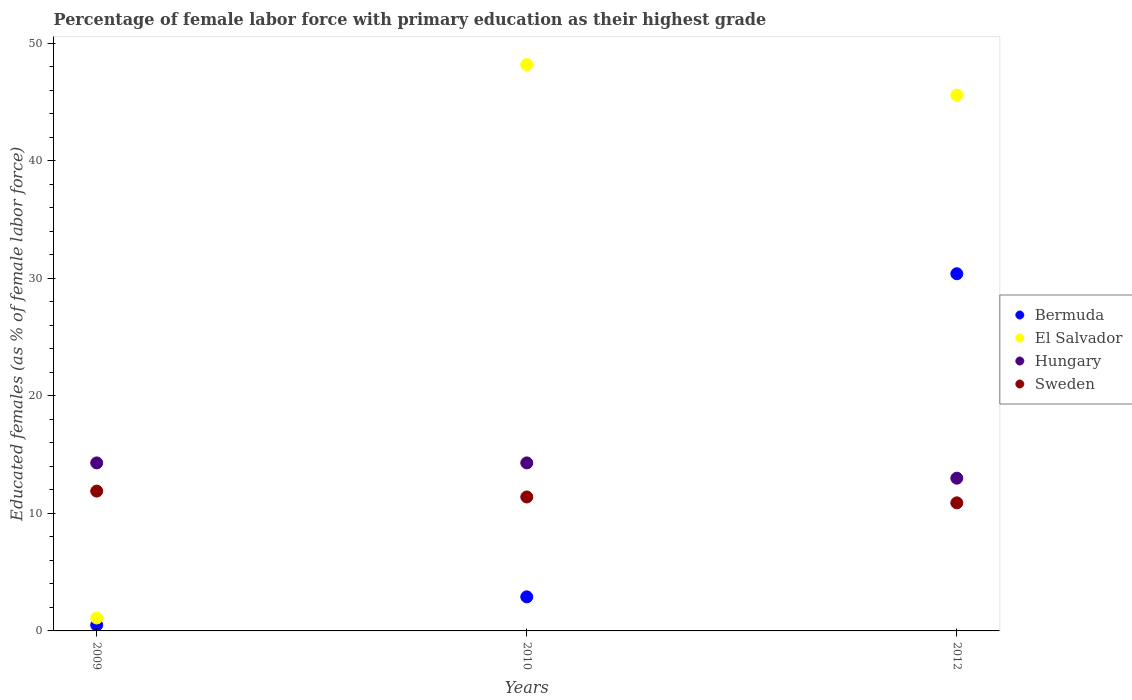What is the percentage of female labor force with primary education in Hungary in 2012?
Keep it short and to the point. 13. Across all years, what is the maximum percentage of female labor force with primary education in El Salvador?
Keep it short and to the point. 48.2. Across all years, what is the minimum percentage of female labor force with primary education in El Salvador?
Your answer should be very brief. 1.1. What is the total percentage of female labor force with primary education in El Salvador in the graph?
Give a very brief answer. 94.9. What is the difference between the percentage of female labor force with primary education in El Salvador in 2010 and that in 2012?
Your answer should be compact. 2.6. What is the difference between the percentage of female labor force with primary education in Sweden in 2009 and the percentage of female labor force with primary education in Bermuda in 2012?
Your response must be concise. -18.5. What is the average percentage of female labor force with primary education in Sweden per year?
Your answer should be very brief. 11.4. In the year 2009, what is the difference between the percentage of female labor force with primary education in Sweden and percentage of female labor force with primary education in Hungary?
Provide a succinct answer. -2.4. In how many years, is the percentage of female labor force with primary education in El Salvador greater than 34 %?
Provide a succinct answer. 2. What is the ratio of the percentage of female labor force with primary education in El Salvador in 2009 to that in 2010?
Offer a very short reply. 0.02. What is the difference between the highest and the lowest percentage of female labor force with primary education in Bermuda?
Make the answer very short. 29.9. In how many years, is the percentage of female labor force with primary education in Bermuda greater than the average percentage of female labor force with primary education in Bermuda taken over all years?
Make the answer very short. 1. Is the sum of the percentage of female labor force with primary education in Bermuda in 2009 and 2012 greater than the maximum percentage of female labor force with primary education in El Salvador across all years?
Offer a terse response. No. Does the percentage of female labor force with primary education in Hungary monotonically increase over the years?
Your answer should be compact. No. Is the percentage of female labor force with primary education in Bermuda strictly less than the percentage of female labor force with primary education in Hungary over the years?
Your answer should be compact. No. How many dotlines are there?
Your answer should be very brief. 4. What is the difference between two consecutive major ticks on the Y-axis?
Keep it short and to the point. 10. Are the values on the major ticks of Y-axis written in scientific E-notation?
Offer a terse response. No. Where does the legend appear in the graph?
Keep it short and to the point. Center right. How many legend labels are there?
Provide a short and direct response. 4. How are the legend labels stacked?
Make the answer very short. Vertical. What is the title of the graph?
Offer a very short reply. Percentage of female labor force with primary education as their highest grade. What is the label or title of the Y-axis?
Provide a short and direct response. Educated females (as % of female labor force). What is the Educated females (as % of female labor force) in Bermuda in 2009?
Provide a short and direct response. 0.5. What is the Educated females (as % of female labor force) in El Salvador in 2009?
Your answer should be very brief. 1.1. What is the Educated females (as % of female labor force) of Hungary in 2009?
Provide a succinct answer. 14.3. What is the Educated females (as % of female labor force) in Sweden in 2009?
Offer a terse response. 11.9. What is the Educated females (as % of female labor force) in Bermuda in 2010?
Provide a short and direct response. 2.9. What is the Educated females (as % of female labor force) in El Salvador in 2010?
Your response must be concise. 48.2. What is the Educated females (as % of female labor force) in Hungary in 2010?
Your answer should be compact. 14.3. What is the Educated females (as % of female labor force) in Sweden in 2010?
Offer a terse response. 11.4. What is the Educated females (as % of female labor force) in Bermuda in 2012?
Ensure brevity in your answer.  30.4. What is the Educated females (as % of female labor force) of El Salvador in 2012?
Offer a terse response. 45.6. What is the Educated females (as % of female labor force) of Hungary in 2012?
Make the answer very short. 13. What is the Educated females (as % of female labor force) in Sweden in 2012?
Keep it short and to the point. 10.9. Across all years, what is the maximum Educated females (as % of female labor force) in Bermuda?
Provide a succinct answer. 30.4. Across all years, what is the maximum Educated females (as % of female labor force) in El Salvador?
Give a very brief answer. 48.2. Across all years, what is the maximum Educated females (as % of female labor force) of Hungary?
Offer a terse response. 14.3. Across all years, what is the maximum Educated females (as % of female labor force) in Sweden?
Offer a terse response. 11.9. Across all years, what is the minimum Educated females (as % of female labor force) of Bermuda?
Your answer should be compact. 0.5. Across all years, what is the minimum Educated females (as % of female labor force) in El Salvador?
Give a very brief answer. 1.1. Across all years, what is the minimum Educated females (as % of female labor force) in Sweden?
Your answer should be compact. 10.9. What is the total Educated females (as % of female labor force) of Bermuda in the graph?
Provide a succinct answer. 33.8. What is the total Educated females (as % of female labor force) of El Salvador in the graph?
Your answer should be very brief. 94.9. What is the total Educated females (as % of female labor force) of Hungary in the graph?
Provide a short and direct response. 41.6. What is the total Educated females (as % of female labor force) in Sweden in the graph?
Provide a succinct answer. 34.2. What is the difference between the Educated females (as % of female labor force) in Bermuda in 2009 and that in 2010?
Your answer should be very brief. -2.4. What is the difference between the Educated females (as % of female labor force) in El Salvador in 2009 and that in 2010?
Ensure brevity in your answer.  -47.1. What is the difference between the Educated females (as % of female labor force) in Sweden in 2009 and that in 2010?
Offer a very short reply. 0.5. What is the difference between the Educated females (as % of female labor force) in Bermuda in 2009 and that in 2012?
Your response must be concise. -29.9. What is the difference between the Educated females (as % of female labor force) in El Salvador in 2009 and that in 2012?
Give a very brief answer. -44.5. What is the difference between the Educated females (as % of female labor force) of Bermuda in 2010 and that in 2012?
Give a very brief answer. -27.5. What is the difference between the Educated females (as % of female labor force) in El Salvador in 2010 and that in 2012?
Your response must be concise. 2.6. What is the difference between the Educated females (as % of female labor force) of Sweden in 2010 and that in 2012?
Your response must be concise. 0.5. What is the difference between the Educated females (as % of female labor force) of Bermuda in 2009 and the Educated females (as % of female labor force) of El Salvador in 2010?
Offer a very short reply. -47.7. What is the difference between the Educated females (as % of female labor force) of Bermuda in 2009 and the Educated females (as % of female labor force) of Hungary in 2010?
Keep it short and to the point. -13.8. What is the difference between the Educated females (as % of female labor force) of Bermuda in 2009 and the Educated females (as % of female labor force) of Sweden in 2010?
Offer a very short reply. -10.9. What is the difference between the Educated females (as % of female labor force) in El Salvador in 2009 and the Educated females (as % of female labor force) in Hungary in 2010?
Make the answer very short. -13.2. What is the difference between the Educated females (as % of female labor force) of Bermuda in 2009 and the Educated females (as % of female labor force) of El Salvador in 2012?
Offer a terse response. -45.1. What is the difference between the Educated females (as % of female labor force) of Bermuda in 2009 and the Educated females (as % of female labor force) of Sweden in 2012?
Make the answer very short. -10.4. What is the difference between the Educated females (as % of female labor force) of El Salvador in 2009 and the Educated females (as % of female labor force) of Hungary in 2012?
Give a very brief answer. -11.9. What is the difference between the Educated females (as % of female labor force) of El Salvador in 2009 and the Educated females (as % of female labor force) of Sweden in 2012?
Provide a short and direct response. -9.8. What is the difference between the Educated females (as % of female labor force) in Bermuda in 2010 and the Educated females (as % of female labor force) in El Salvador in 2012?
Keep it short and to the point. -42.7. What is the difference between the Educated females (as % of female labor force) of Bermuda in 2010 and the Educated females (as % of female labor force) of Sweden in 2012?
Offer a very short reply. -8. What is the difference between the Educated females (as % of female labor force) in El Salvador in 2010 and the Educated females (as % of female labor force) in Hungary in 2012?
Offer a terse response. 35.2. What is the difference between the Educated females (as % of female labor force) of El Salvador in 2010 and the Educated females (as % of female labor force) of Sweden in 2012?
Your answer should be compact. 37.3. What is the average Educated females (as % of female labor force) in Bermuda per year?
Offer a very short reply. 11.27. What is the average Educated females (as % of female labor force) of El Salvador per year?
Your answer should be very brief. 31.63. What is the average Educated females (as % of female labor force) in Hungary per year?
Your answer should be very brief. 13.87. In the year 2009, what is the difference between the Educated females (as % of female labor force) in Bermuda and Educated females (as % of female labor force) in Sweden?
Keep it short and to the point. -11.4. In the year 2009, what is the difference between the Educated females (as % of female labor force) of El Salvador and Educated females (as % of female labor force) of Hungary?
Keep it short and to the point. -13.2. In the year 2009, what is the difference between the Educated females (as % of female labor force) in El Salvador and Educated females (as % of female labor force) in Sweden?
Offer a very short reply. -10.8. In the year 2010, what is the difference between the Educated females (as % of female labor force) in Bermuda and Educated females (as % of female labor force) in El Salvador?
Give a very brief answer. -45.3. In the year 2010, what is the difference between the Educated females (as % of female labor force) of Bermuda and Educated females (as % of female labor force) of Hungary?
Keep it short and to the point. -11.4. In the year 2010, what is the difference between the Educated females (as % of female labor force) in El Salvador and Educated females (as % of female labor force) in Hungary?
Give a very brief answer. 33.9. In the year 2010, what is the difference between the Educated females (as % of female labor force) of El Salvador and Educated females (as % of female labor force) of Sweden?
Make the answer very short. 36.8. In the year 2012, what is the difference between the Educated females (as % of female labor force) in Bermuda and Educated females (as % of female labor force) in El Salvador?
Offer a terse response. -15.2. In the year 2012, what is the difference between the Educated females (as % of female labor force) of Bermuda and Educated females (as % of female labor force) of Sweden?
Provide a short and direct response. 19.5. In the year 2012, what is the difference between the Educated females (as % of female labor force) of El Salvador and Educated females (as % of female labor force) of Hungary?
Your answer should be compact. 32.6. In the year 2012, what is the difference between the Educated females (as % of female labor force) of El Salvador and Educated females (as % of female labor force) of Sweden?
Your response must be concise. 34.7. What is the ratio of the Educated females (as % of female labor force) of Bermuda in 2009 to that in 2010?
Keep it short and to the point. 0.17. What is the ratio of the Educated females (as % of female labor force) of El Salvador in 2009 to that in 2010?
Your answer should be very brief. 0.02. What is the ratio of the Educated females (as % of female labor force) in Sweden in 2009 to that in 2010?
Make the answer very short. 1.04. What is the ratio of the Educated females (as % of female labor force) of Bermuda in 2009 to that in 2012?
Provide a short and direct response. 0.02. What is the ratio of the Educated females (as % of female labor force) in El Salvador in 2009 to that in 2012?
Offer a terse response. 0.02. What is the ratio of the Educated females (as % of female labor force) of Sweden in 2009 to that in 2012?
Make the answer very short. 1.09. What is the ratio of the Educated females (as % of female labor force) of Bermuda in 2010 to that in 2012?
Ensure brevity in your answer.  0.1. What is the ratio of the Educated females (as % of female labor force) of El Salvador in 2010 to that in 2012?
Keep it short and to the point. 1.06. What is the ratio of the Educated females (as % of female labor force) of Hungary in 2010 to that in 2012?
Ensure brevity in your answer.  1.1. What is the ratio of the Educated females (as % of female labor force) in Sweden in 2010 to that in 2012?
Offer a terse response. 1.05. What is the difference between the highest and the second highest Educated females (as % of female labor force) of Bermuda?
Your response must be concise. 27.5. What is the difference between the highest and the lowest Educated females (as % of female labor force) in Bermuda?
Your answer should be very brief. 29.9. What is the difference between the highest and the lowest Educated females (as % of female labor force) of El Salvador?
Give a very brief answer. 47.1. What is the difference between the highest and the lowest Educated females (as % of female labor force) of Hungary?
Offer a very short reply. 1.3. 